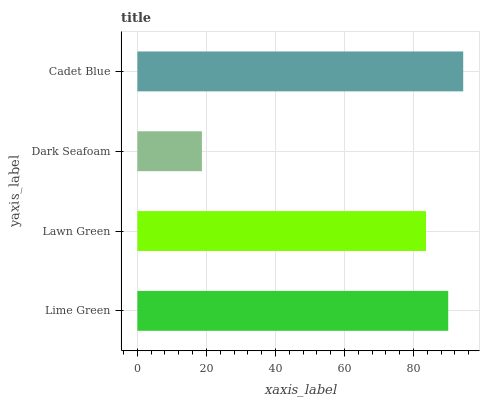Is Dark Seafoam the minimum?
Answer yes or no. Yes. Is Cadet Blue the maximum?
Answer yes or no. Yes. Is Lawn Green the minimum?
Answer yes or no. No. Is Lawn Green the maximum?
Answer yes or no. No. Is Lime Green greater than Lawn Green?
Answer yes or no. Yes. Is Lawn Green less than Lime Green?
Answer yes or no. Yes. Is Lawn Green greater than Lime Green?
Answer yes or no. No. Is Lime Green less than Lawn Green?
Answer yes or no. No. Is Lime Green the high median?
Answer yes or no. Yes. Is Lawn Green the low median?
Answer yes or no. Yes. Is Cadet Blue the high median?
Answer yes or no. No. Is Cadet Blue the low median?
Answer yes or no. No. 